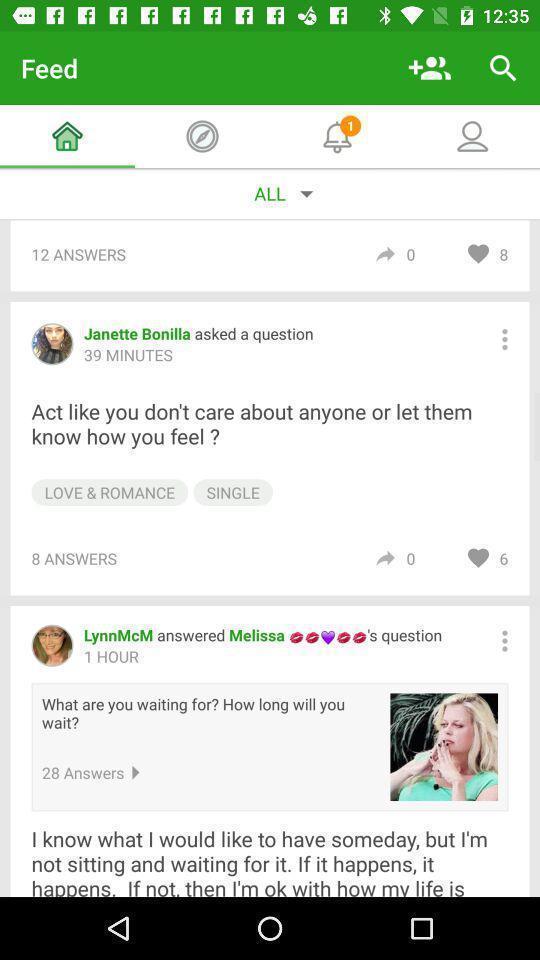Give me a summary of this screen capture. Screen showing feed in an social application. 